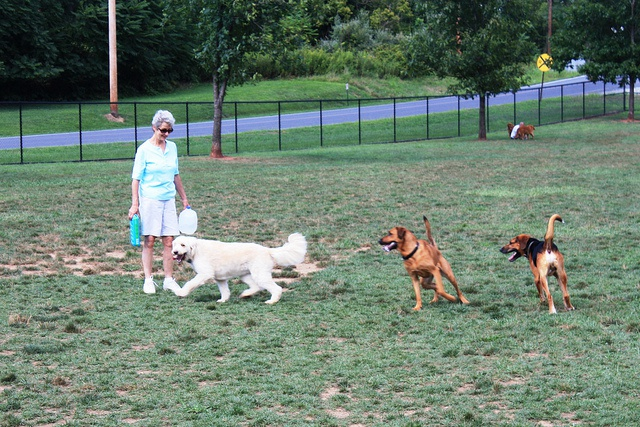Describe the objects in this image and their specific colors. I can see people in black, white, darkgray, lightpink, and lightblue tones, dog in black, white, darkgray, and gray tones, dog in black, salmon, brown, tan, and maroon tones, dog in black, brown, maroon, and tan tones, and dog in black, maroon, gray, and brown tones in this image. 